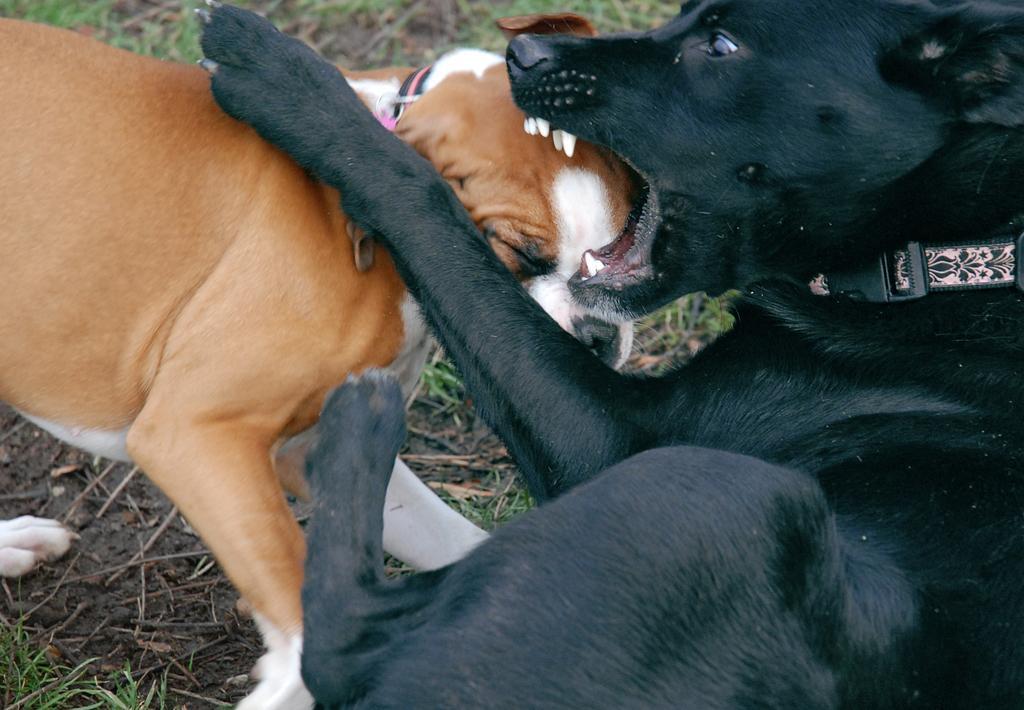How would you summarize this image in a sentence or two? In this picture we can see two dogs. There are belts visible on these dogs. We can see some grass and twigs on the ground. 